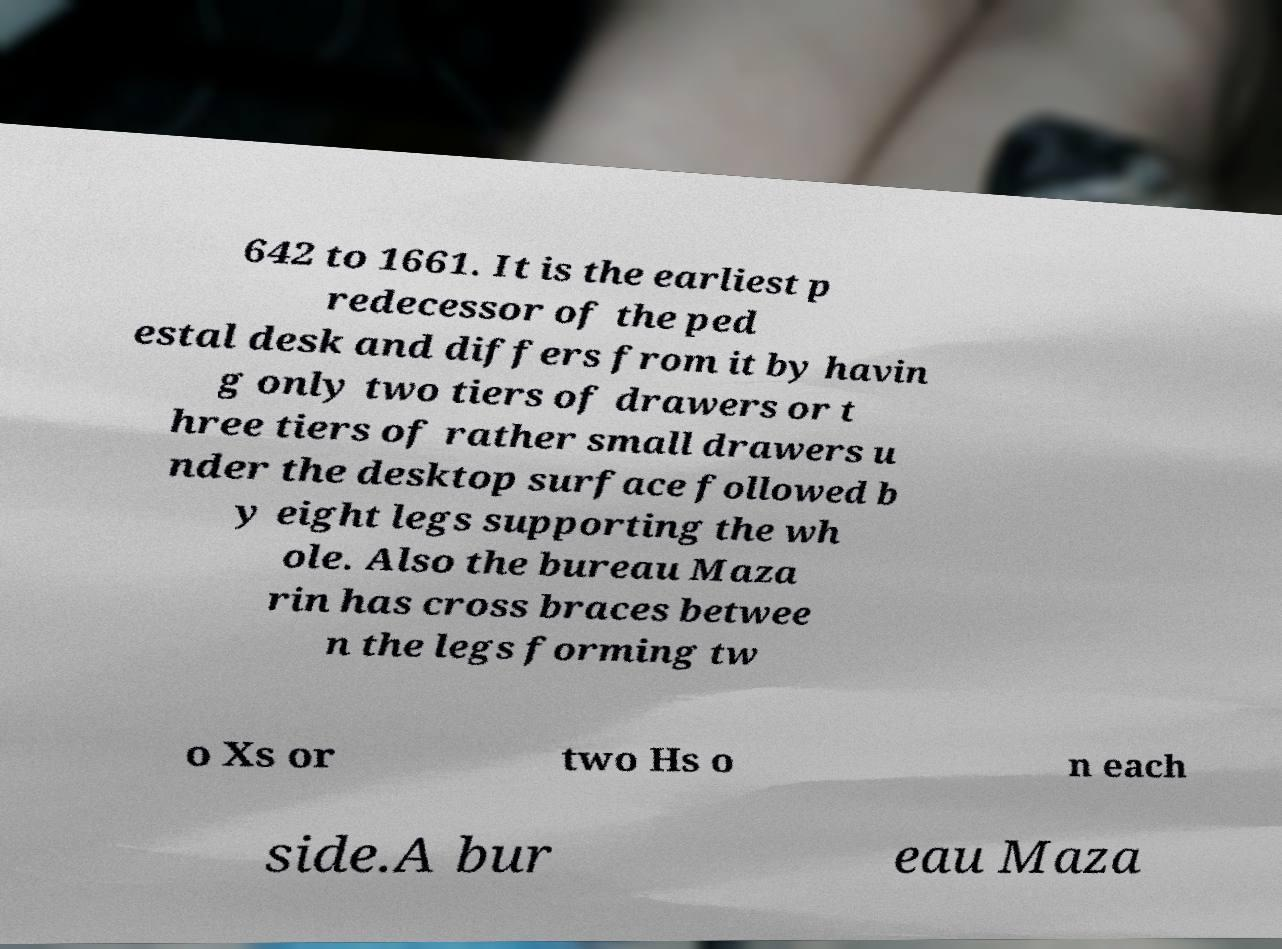Can you accurately transcribe the text from the provided image for me? 642 to 1661. It is the earliest p redecessor of the ped estal desk and differs from it by havin g only two tiers of drawers or t hree tiers of rather small drawers u nder the desktop surface followed b y eight legs supporting the wh ole. Also the bureau Maza rin has cross braces betwee n the legs forming tw o Xs or two Hs o n each side.A bur eau Maza 